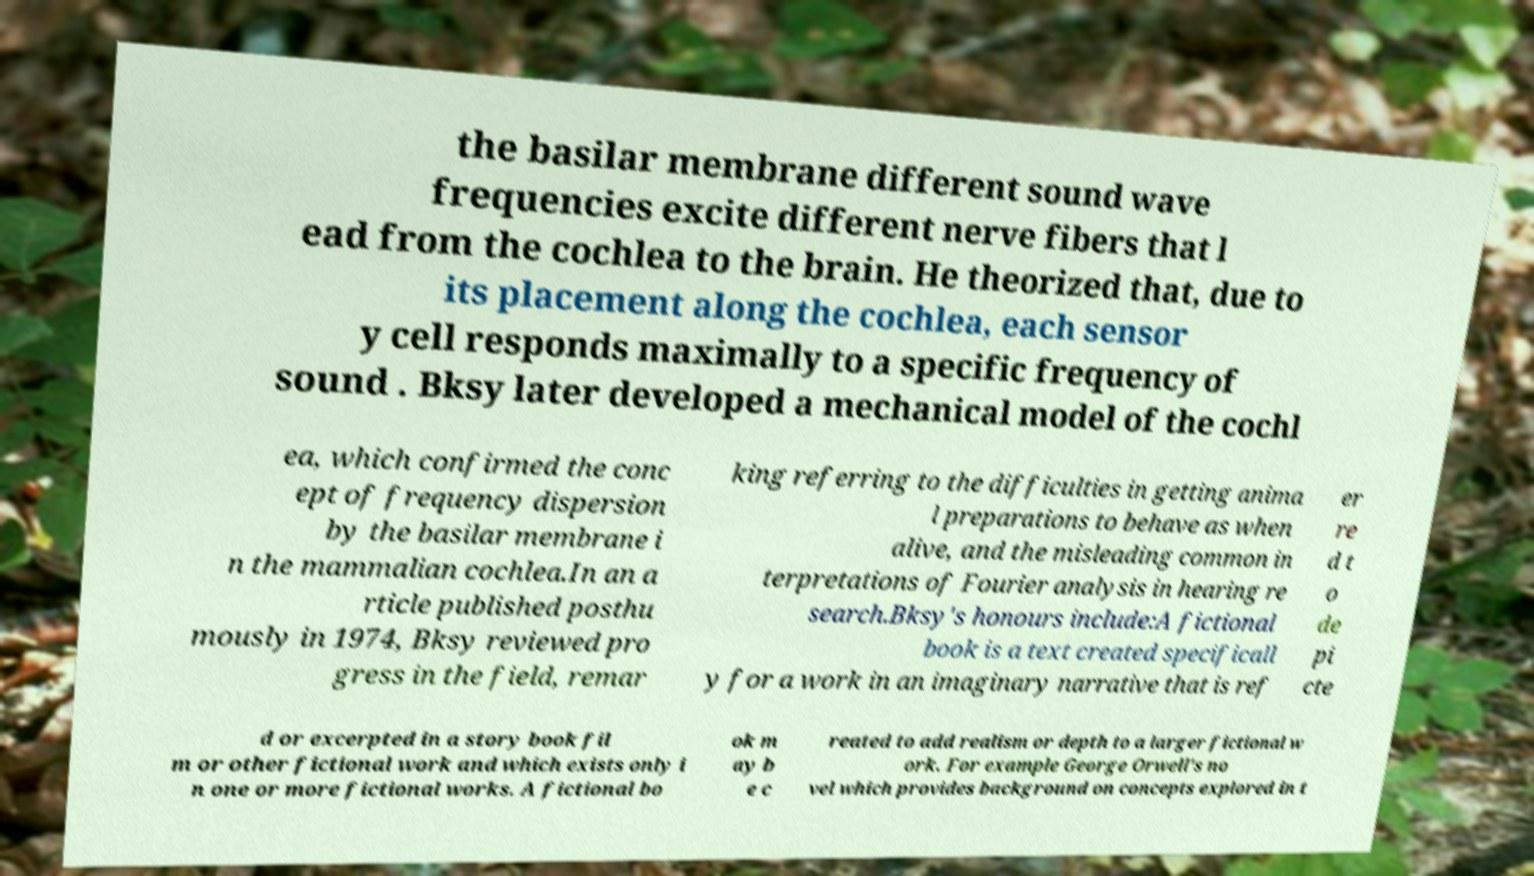Can you read and provide the text displayed in the image?This photo seems to have some interesting text. Can you extract and type it out for me? the basilar membrane different sound wave frequencies excite different nerve fibers that l ead from the cochlea to the brain. He theorized that, due to its placement along the cochlea, each sensor y cell responds maximally to a specific frequency of sound . Bksy later developed a mechanical model of the cochl ea, which confirmed the conc ept of frequency dispersion by the basilar membrane i n the mammalian cochlea.In an a rticle published posthu mously in 1974, Bksy reviewed pro gress in the field, remar king referring to the difficulties in getting anima l preparations to behave as when alive, and the misleading common in terpretations of Fourier analysis in hearing re search.Bksy's honours include:A fictional book is a text created specificall y for a work in an imaginary narrative that is ref er re d t o de pi cte d or excerpted in a story book fil m or other fictional work and which exists only i n one or more fictional works. A fictional bo ok m ay b e c reated to add realism or depth to a larger fictional w ork. For example George Orwell's no vel which provides background on concepts explored in t 